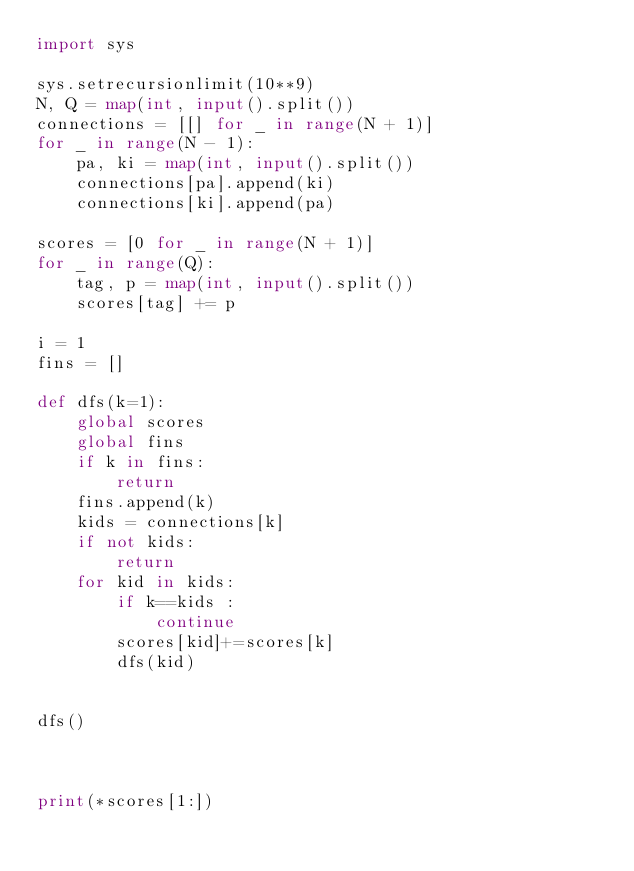Convert code to text. <code><loc_0><loc_0><loc_500><loc_500><_Python_>import sys

sys.setrecursionlimit(10**9)
N, Q = map(int, input().split())
connections = [[] for _ in range(N + 1)]
for _ in range(N - 1):
    pa, ki = map(int, input().split())
    connections[pa].append(ki)
    connections[ki].append(pa)

scores = [0 for _ in range(N + 1)]
for _ in range(Q):
    tag, p = map(int, input().split())
    scores[tag] += p

i = 1
fins = []

def dfs(k=1):
    global scores
    global fins
    if k in fins:
        return
    fins.append(k)
    kids = connections[k]
    if not kids:
        return
    for kid in kids:
        if k==kids :
            continue
        scores[kid]+=scores[k]
        dfs(kid)


dfs()



print(*scores[1:])</code> 